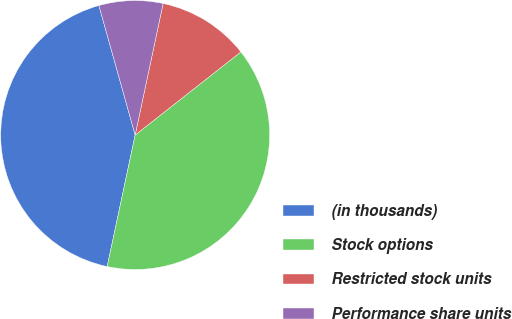Convert chart to OTSL. <chart><loc_0><loc_0><loc_500><loc_500><pie_chart><fcel>(in thousands)<fcel>Stock options<fcel>Restricted stock units<fcel>Performance share units<nl><fcel>42.32%<fcel>38.94%<fcel>11.06%<fcel>7.68%<nl></chart> 